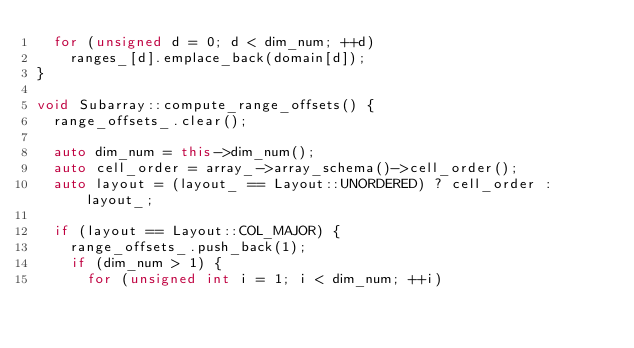<code> <loc_0><loc_0><loc_500><loc_500><_C++_>  for (unsigned d = 0; d < dim_num; ++d)
    ranges_[d].emplace_back(domain[d]);
}

void Subarray::compute_range_offsets() {
  range_offsets_.clear();

  auto dim_num = this->dim_num();
  auto cell_order = array_->array_schema()->cell_order();
  auto layout = (layout_ == Layout::UNORDERED) ? cell_order : layout_;

  if (layout == Layout::COL_MAJOR) {
    range_offsets_.push_back(1);
    if (dim_num > 1) {
      for (unsigned int i = 1; i < dim_num; ++i)</code> 